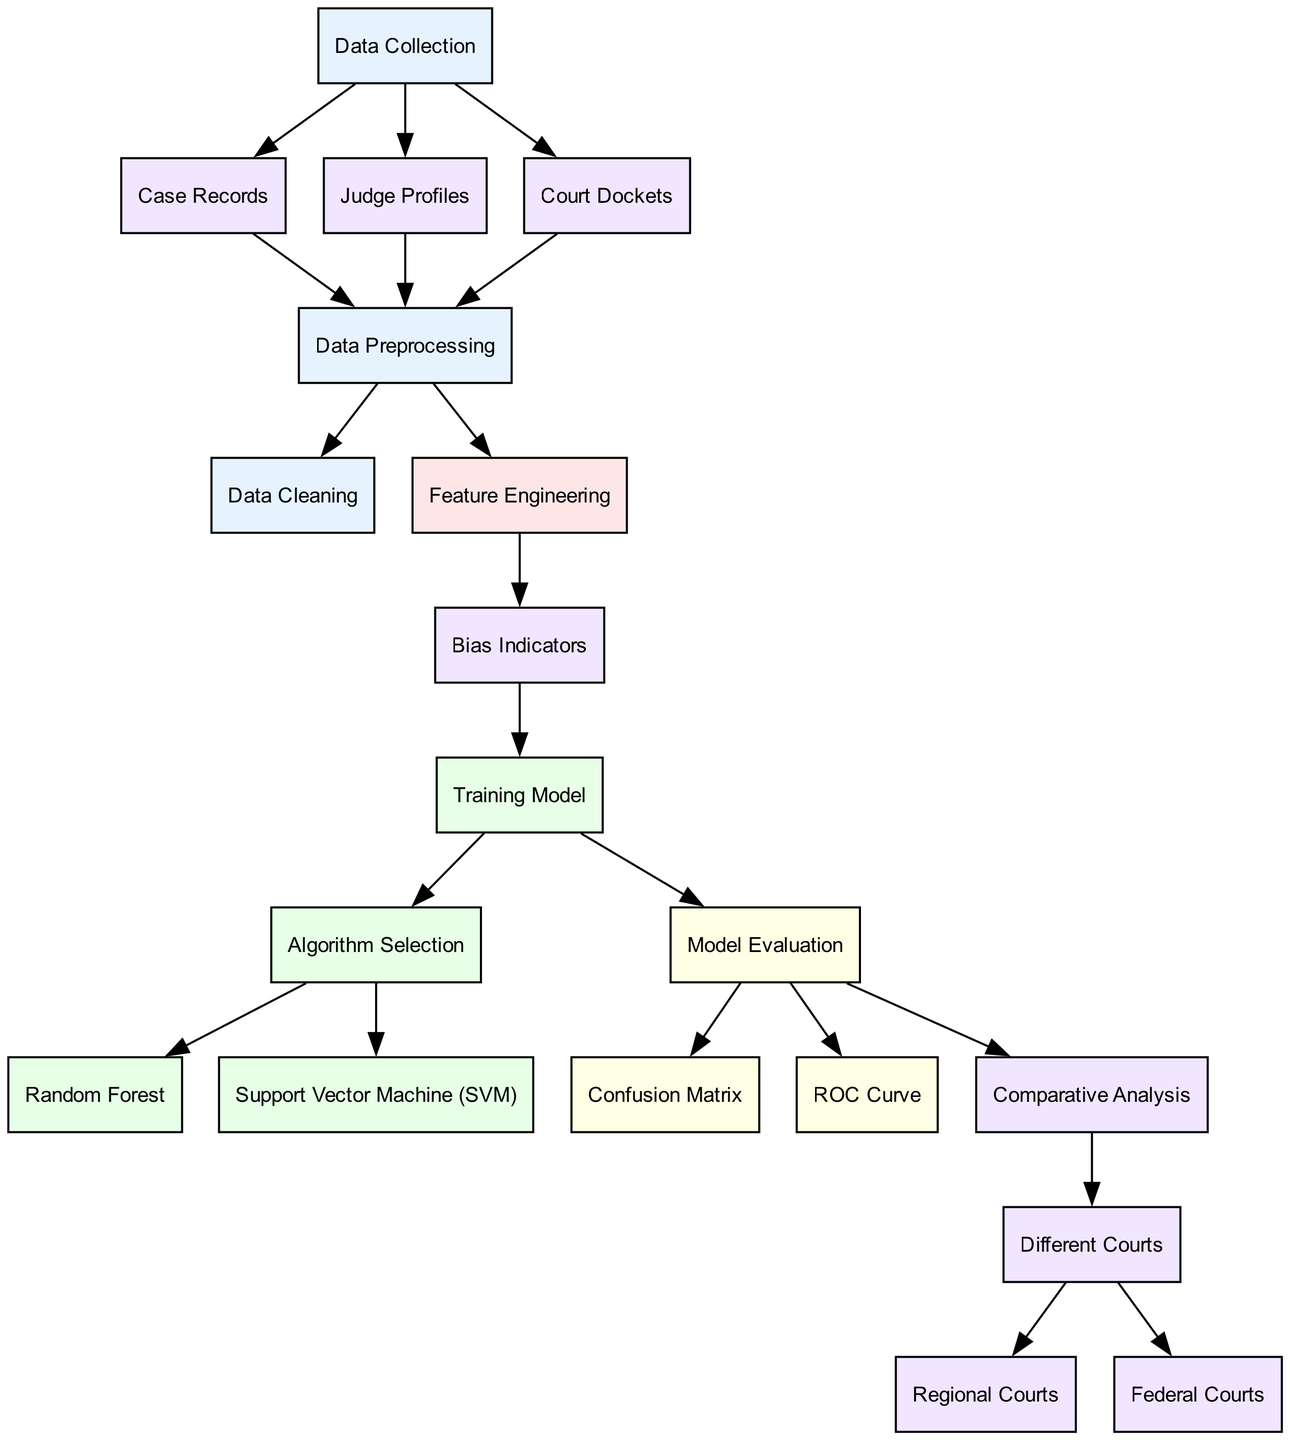What are the types of data collected in this model? The diagram lists three types of data collected: Case Records, Judge Profiles, and Court Dockets, all originating from the Data Collection node.
Answer: Case Records, Judge Profiles, Court Dockets How many nodes are present in the diagram? By counting all defined nodes in the diagram, we find a total of 15 distinct nodes mentioned within the data structure provided.
Answer: 15 What is the first step after Data Preprocessing? According to the diagram, the first steps that follow Data Preprocessing are Data Cleaning and Feature Engineering, but in a sequence, it leads to Data Cleaning first.
Answer: Data Cleaning Which algorithms are selected for model training? The diagram specifies two algorithms used for training models: Random Forest and Support Vector Machine (SVM), both stemming from the Algorithm Selection node.
Answer: Random Forest, Support Vector Machine (SVM) What type of analysis is conducted after Model Evaluation? After Model Evaluation, the diagram directs to Comparative Analysis, indicating that the results of evaluation are analyzed comparatively.
Answer: Comparative Analysis Which type of courts are compared in the Comparative Analysis? The Comparative Analysis includes comparisons between Different Courts, which are further broken down into Regional Courts and Federal Courts as indicated in the edges connected to the Different Courts node.
Answer: Regional Courts, Federal Courts What does the bias indicators node derive from? The Bias Indicators node receives input primarily from the Feature Engineering node, as indicated in the connections shown in the diagram.
Answer: Feature Engineering Which evaluation metric is used in the diagram? The diagram includes two evaluation metrics identified as Confusion Matrix and ROC Curve, both of which are part of the evaluation process after model training.
Answer: Confusion Matrix, ROC Curve 